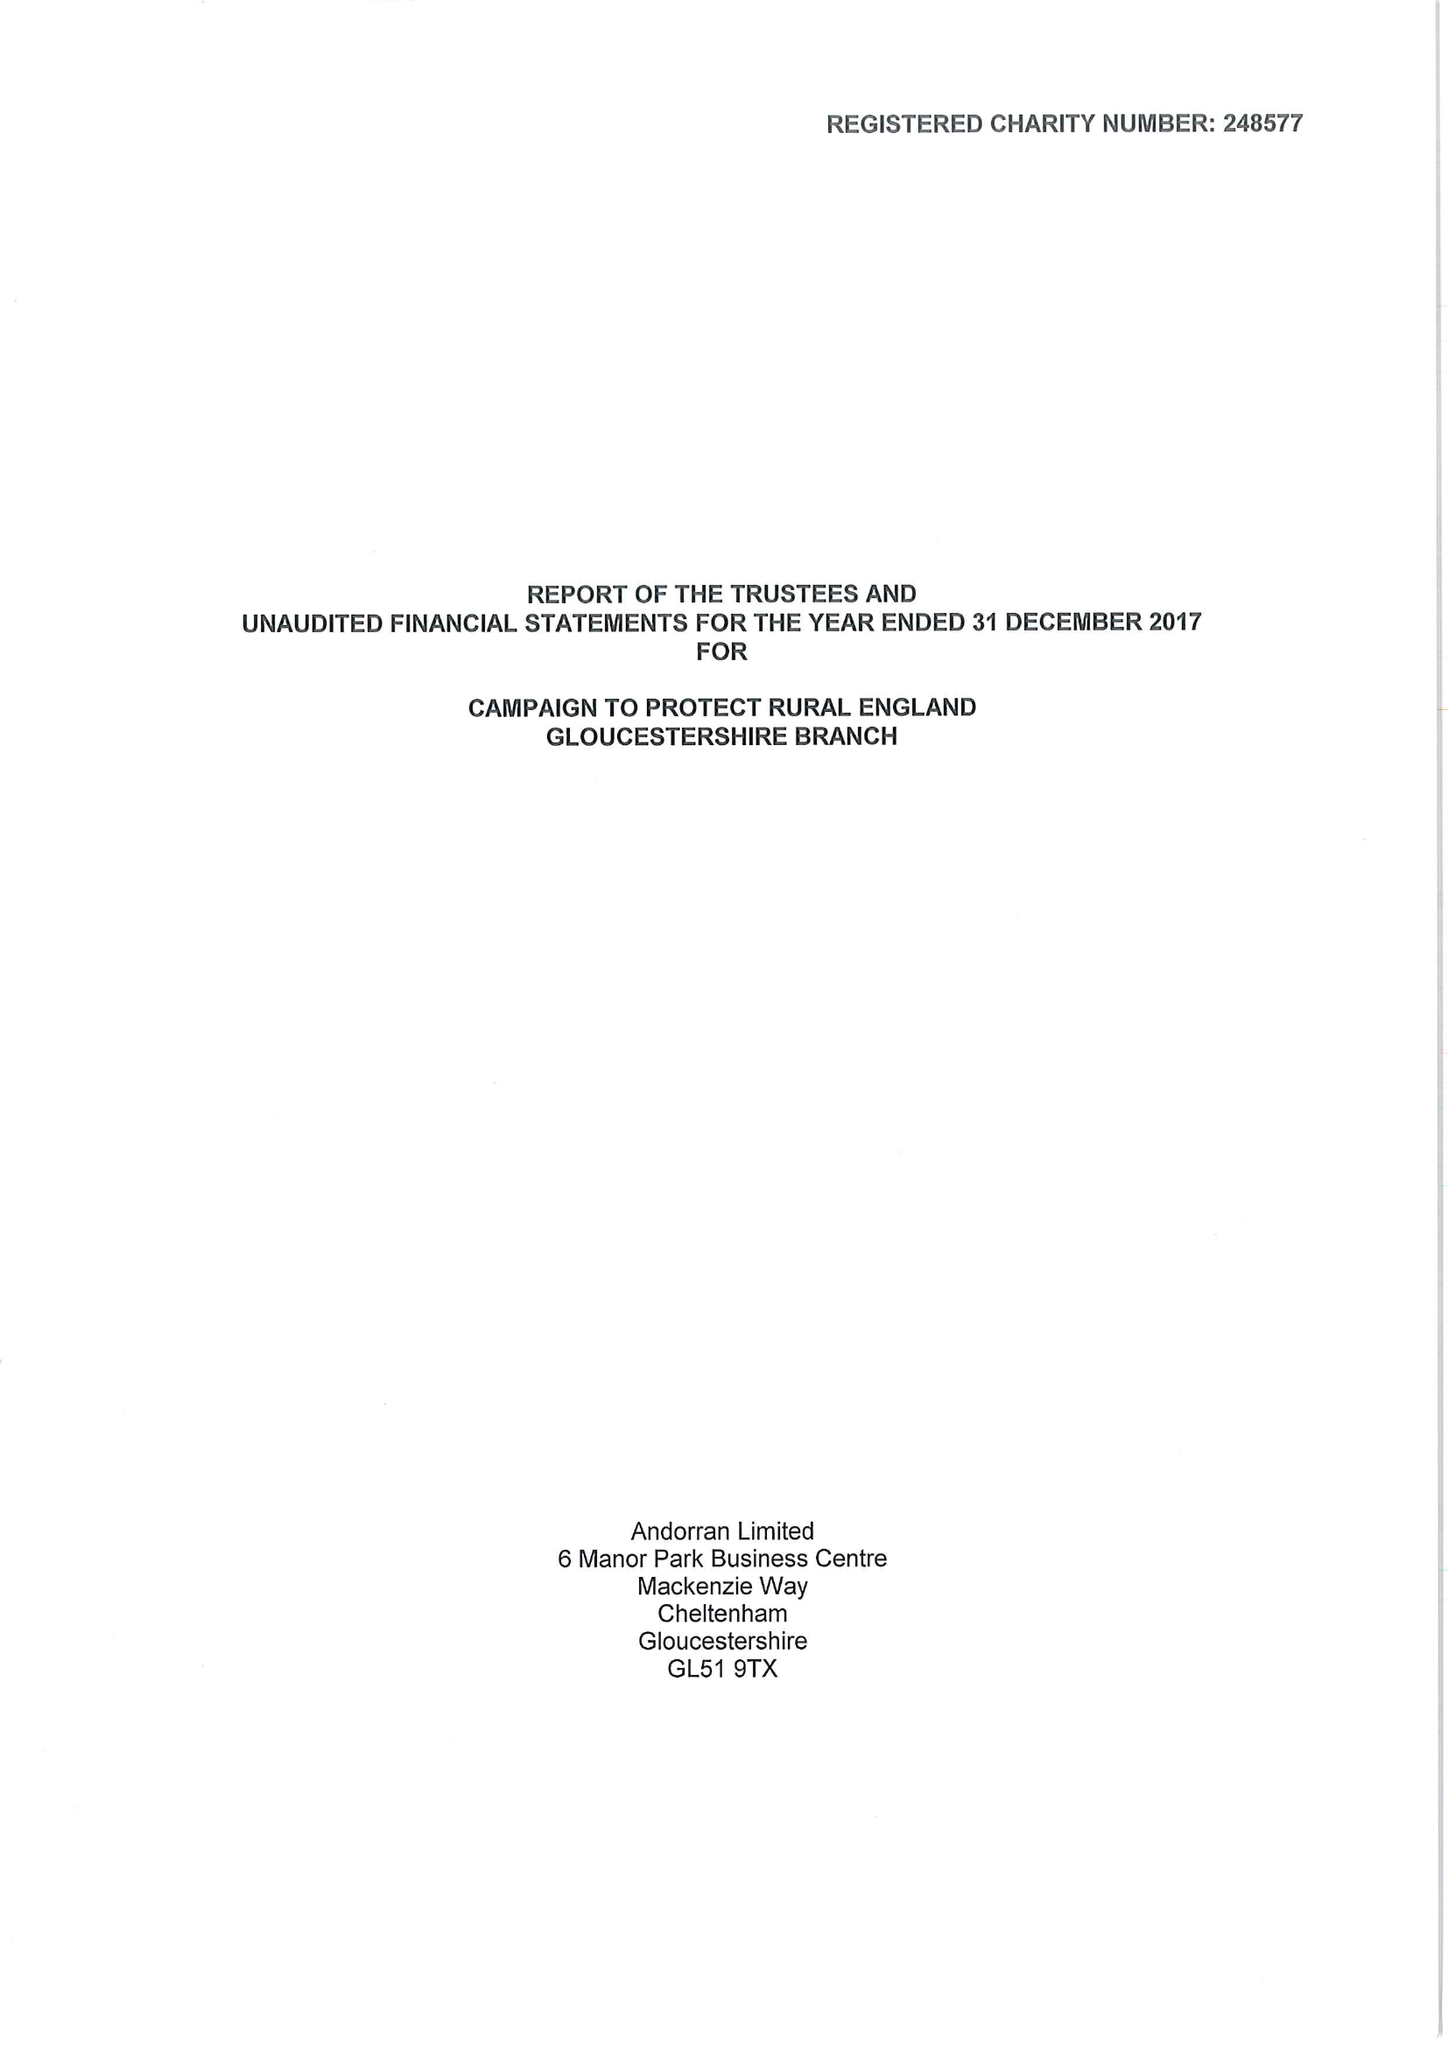What is the value for the charity_name?
Answer the question using a single word or phrase. Campaign To Protect Rural England, Gloucestershire Branch 